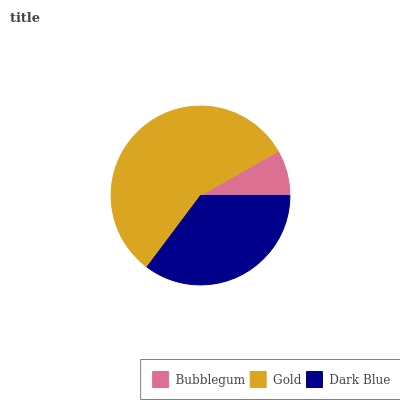Is Bubblegum the minimum?
Answer yes or no. Yes. Is Gold the maximum?
Answer yes or no. Yes. Is Dark Blue the minimum?
Answer yes or no. No. Is Dark Blue the maximum?
Answer yes or no. No. Is Gold greater than Dark Blue?
Answer yes or no. Yes. Is Dark Blue less than Gold?
Answer yes or no. Yes. Is Dark Blue greater than Gold?
Answer yes or no. No. Is Gold less than Dark Blue?
Answer yes or no. No. Is Dark Blue the high median?
Answer yes or no. Yes. Is Dark Blue the low median?
Answer yes or no. Yes. Is Bubblegum the high median?
Answer yes or no. No. Is Bubblegum the low median?
Answer yes or no. No. 